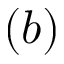<formula> <loc_0><loc_0><loc_500><loc_500>( b )</formula> 